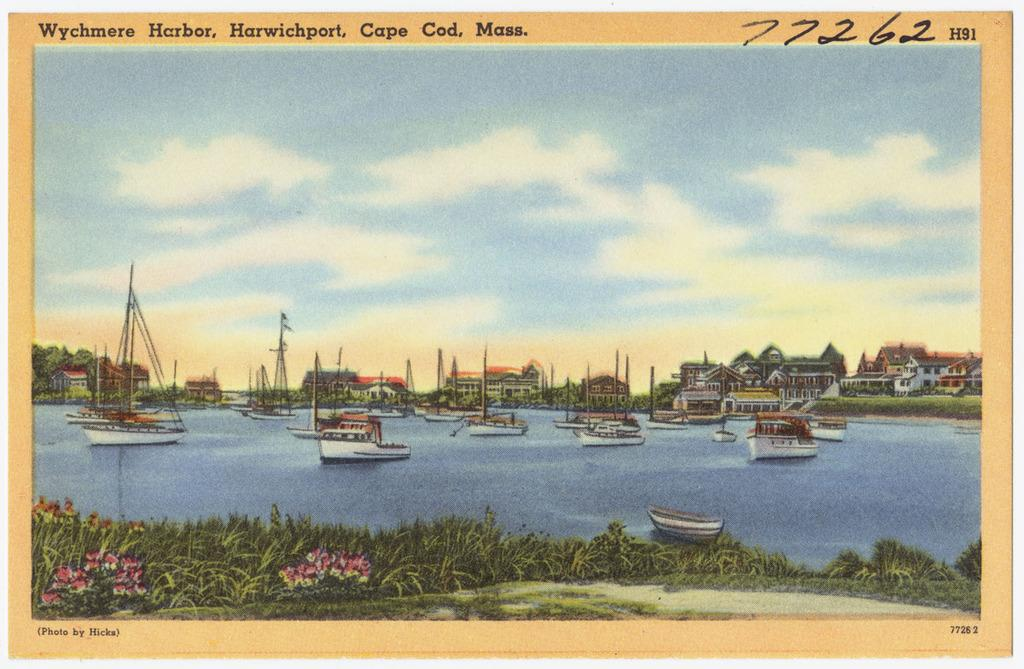<image>
Summarize the visual content of the image. A postcard that is dejecting boats on the water in Cape Cod 